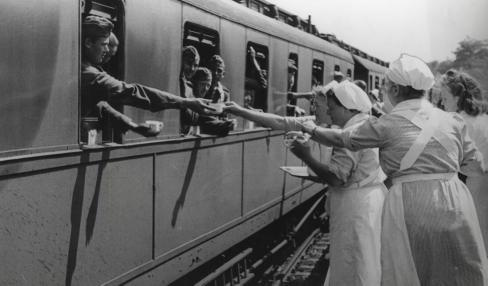Describe the objects in this image and their specific colors. I can see train in darkgray, gray, black, and lightgray tones, people in darkgray, gray, black, and lightgray tones, people in darkgray, gray, black, and lightgray tones, people in black, gray, and darkgray tones, and people in gray, darkgray, and black tones in this image. 